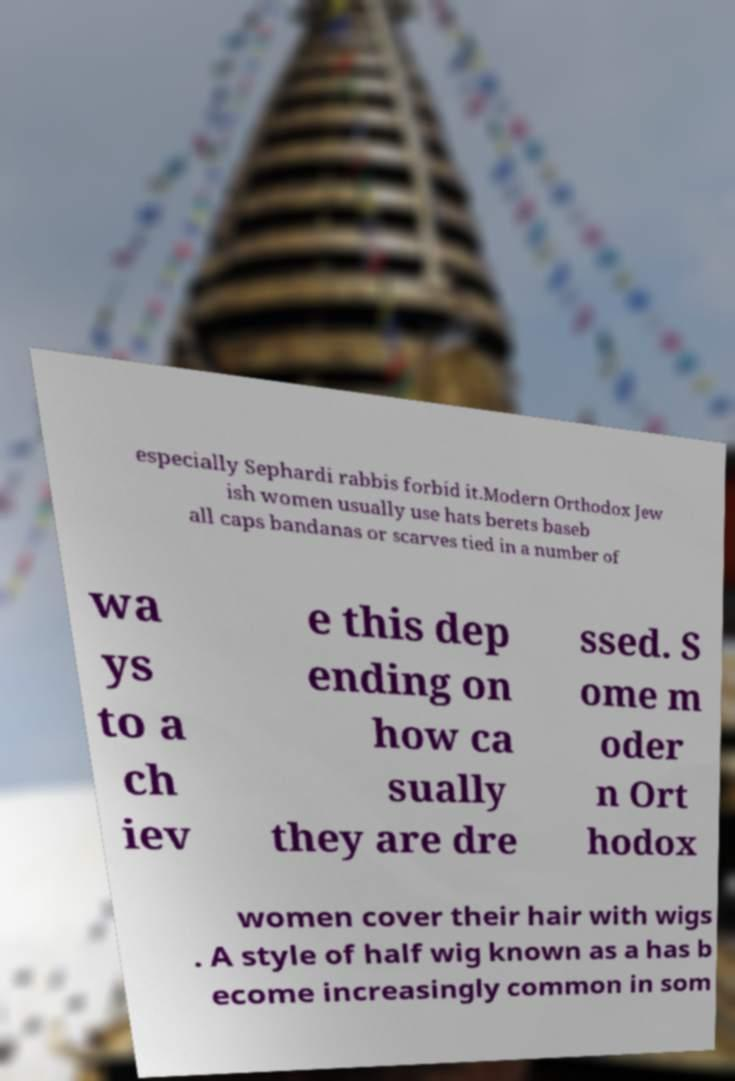Could you extract and type out the text from this image? especially Sephardi rabbis forbid it.Modern Orthodox Jew ish women usually use hats berets baseb all caps bandanas or scarves tied in a number of wa ys to a ch iev e this dep ending on how ca sually they are dre ssed. S ome m oder n Ort hodox women cover their hair with wigs . A style of half wig known as a has b ecome increasingly common in som 